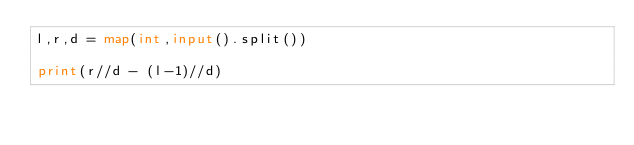Convert code to text. <code><loc_0><loc_0><loc_500><loc_500><_Python_>l,r,d = map(int,input().split())

print(r//d - (l-1)//d)</code> 